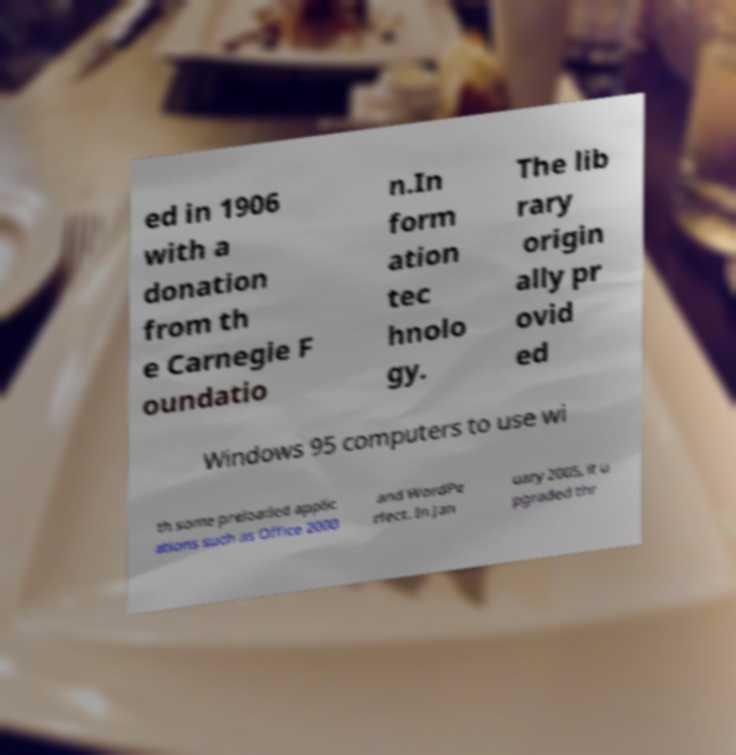Can you read and provide the text displayed in the image?This photo seems to have some interesting text. Can you extract and type it out for me? ed in 1906 with a donation from th e Carnegie F oundatio n.In form ation tec hnolo gy. The lib rary origin ally pr ovid ed Windows 95 computers to use wi th some preloaded applic ations such as Office 2000 and WordPe rfect. In Jan uary 2005, it u pgraded thr 